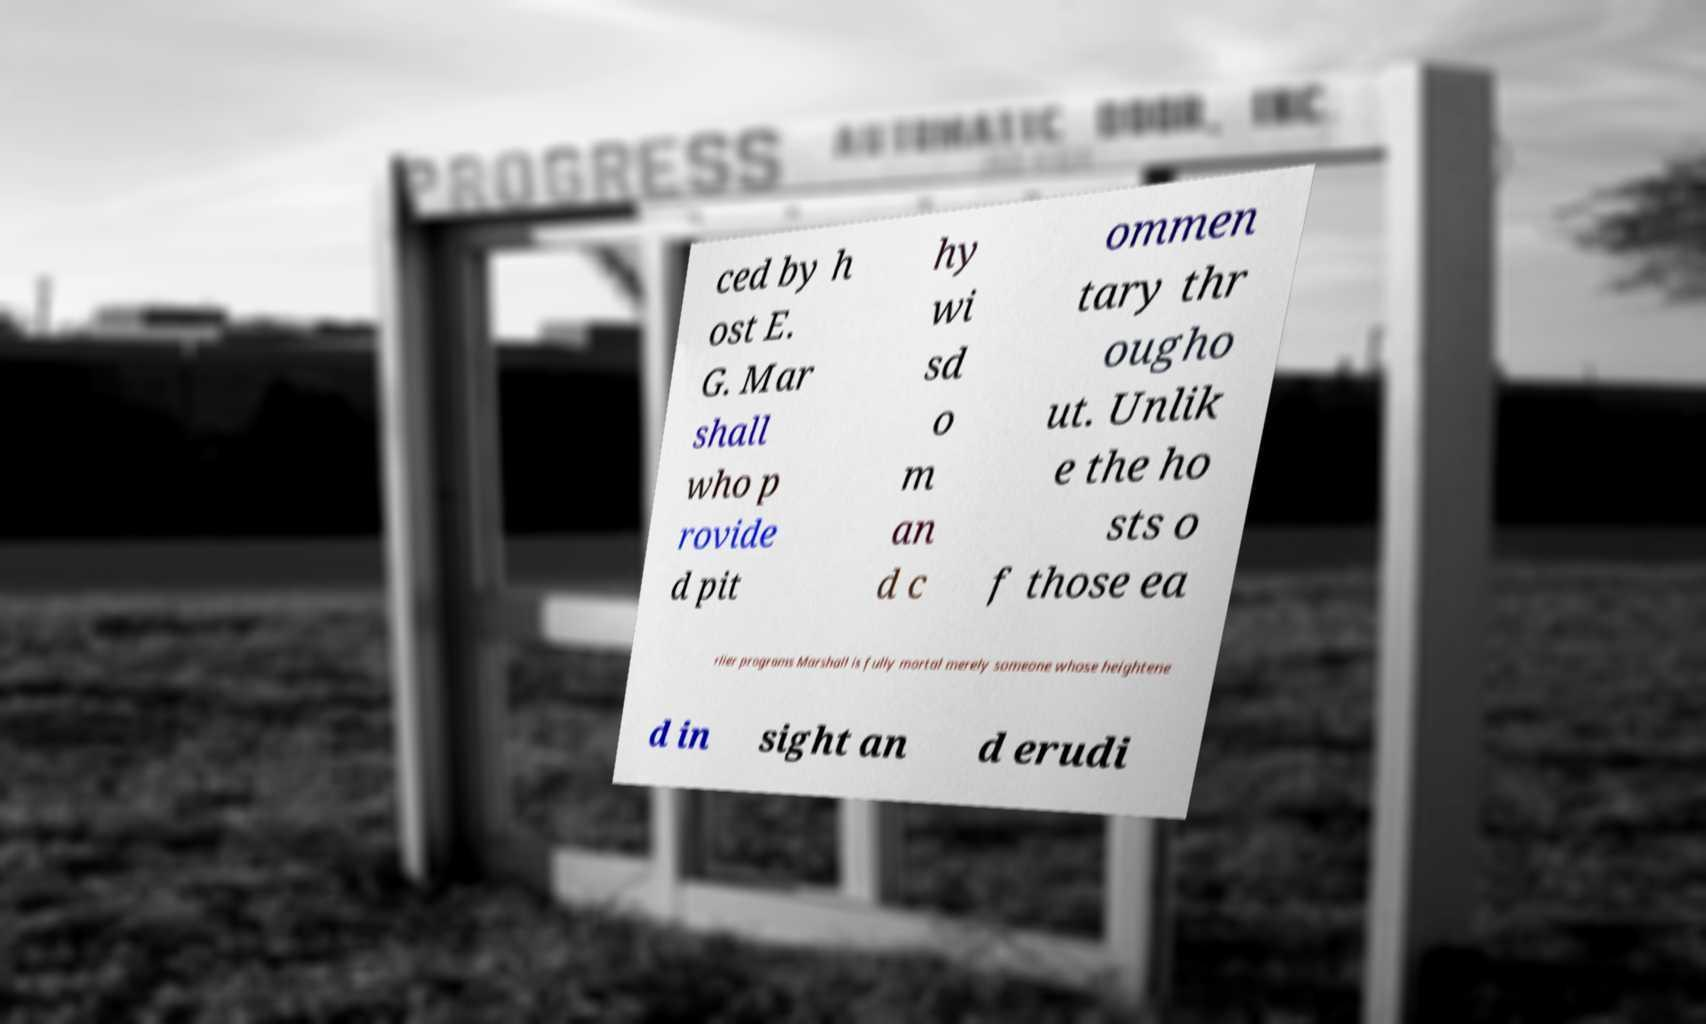Please identify and transcribe the text found in this image. ced by h ost E. G. Mar shall who p rovide d pit hy wi sd o m an d c ommen tary thr ougho ut. Unlik e the ho sts o f those ea rlier programs Marshall is fully mortal merely someone whose heightene d in sight an d erudi 